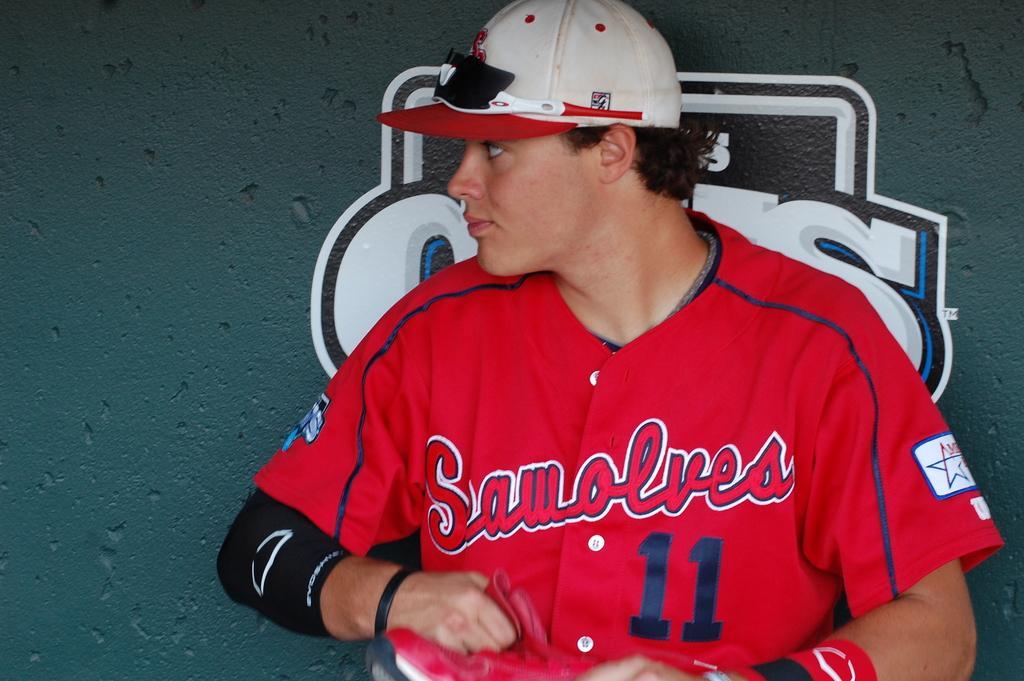Describe this image in one or two sentences. In this image we can see a man with cap. 